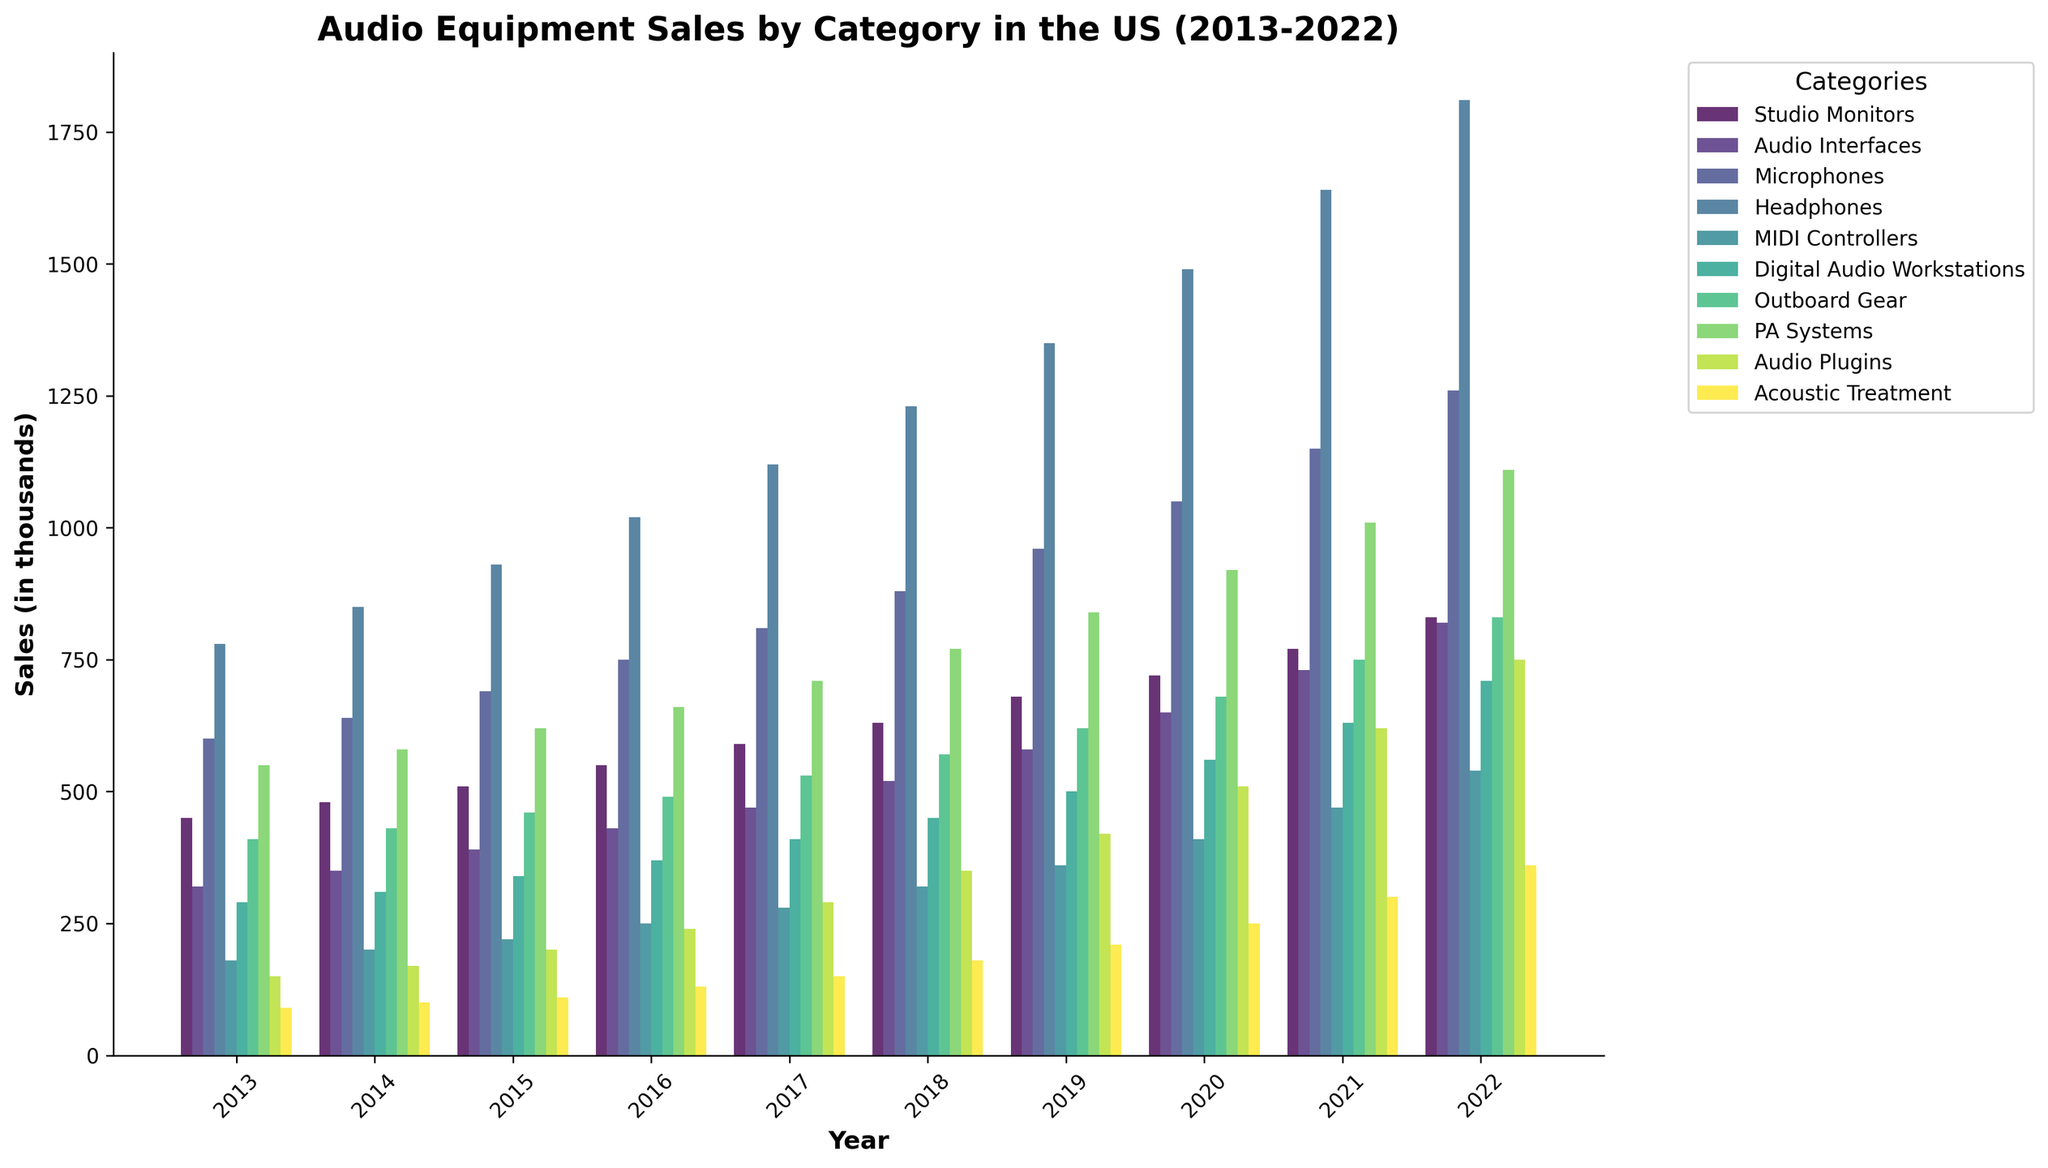What's the highest sales category in 2022? By looking at the heights of the bars for 2022, the highest bar represents Headphones.
Answer: Headphones Which category saw the most growth from 2013 to 2022? To find the category with the most growth, subtract the 2013 value from the 2022 value for each category and compare. Headphones grew from 780 to 1810 (1030 units). This is the highest growth.
Answer: Headphones What are the total sales of Microphones from 2013 to 2022? Add up the sales figures for Microphones for all the years: 600 + 640 + 690 + 750 + 810 + 880 + 960 + 1050 + 1150 + 1260 = 8790.
Answer: 8790 Which year did PA Systems surpass 1000 in sales? Look at the PA Systems bars and identify the first year where the value exceeds 1000. This happened in 2021.
Answer: 2021 How many categories had sales over 800 in 2019? Identify the categories where the sales value in 2019 is greater than 800. Microphones, Headphones, PA Systems, and Outboard Gear had sales over 800.
Answer: 4 Which categories showed consistent growth every year? Check each category’s sales year by year to see if each subsequent year has higher sales than the previous year. Studio Monitors, Audio Interfaces, Microphones, Headphones, MIDI Controllers, Digital Audio Workstations, and Audio Plugins show consistent growth.
Answer: 7 categories Compare the sales of Digital Audio Workstations and MIDI Controllers in 2017. Which had higher sales? Look at the height of the bars for Digital Audio Workstations and MIDI Controllers in 2017 and compare. Digital Audio Workstations had sales of 410, and MIDI Controllers had sales of 280.
Answer: Digital Audio Workstations What are the average sales for Acoustic Treatment between 2013 and 2022? Sum the sales values for Acoustic Treatment for all the years and divide by the number of years. (90 + 100 + 110 + 130 + 150 + 180 + 210 + 250 + 300 + 360) / 10 = 188.
Answer: 188 In which year did Audio Plugins experience the highest increase in sales compared to the previous year? Subtract the previous year's sales from each year's sales for Audio Plugins and identify the highest increase. The highest increase occurred from 2017 to 2018, with an increase of 60.
Answer: 2018 Which category had the least sales in 2013, and what was the amount? Find the shortest bar in 2013. Acoustic Treatment had the least sales with 90.
Answer: Acoustic Treatment (90) 